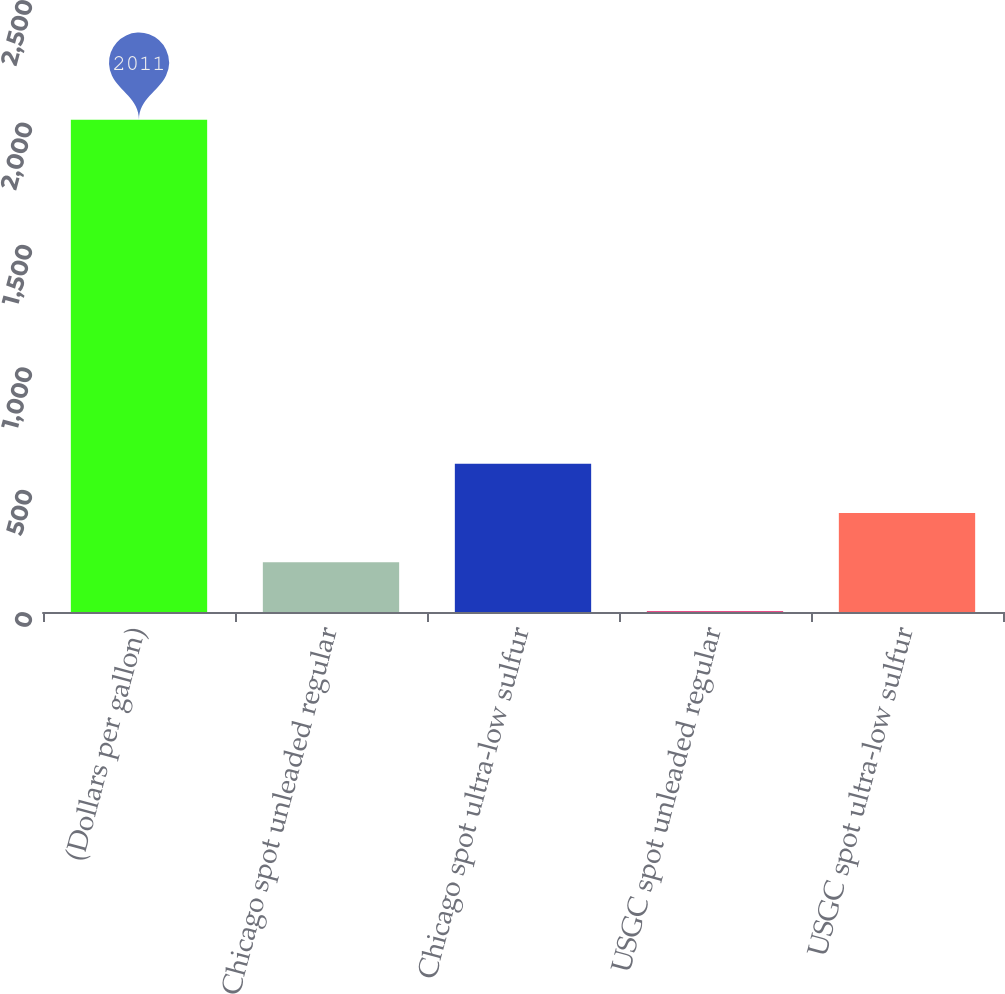Convert chart. <chart><loc_0><loc_0><loc_500><loc_500><bar_chart><fcel>(Dollars per gallon)<fcel>Chicago spot unleaded regular<fcel>Chicago spot ultra-low sulfur<fcel>USGC spot unleaded regular<fcel>USGC spot ultra-low sulfur<nl><fcel>2011<fcel>203.58<fcel>605.24<fcel>2.75<fcel>404.41<nl></chart> 